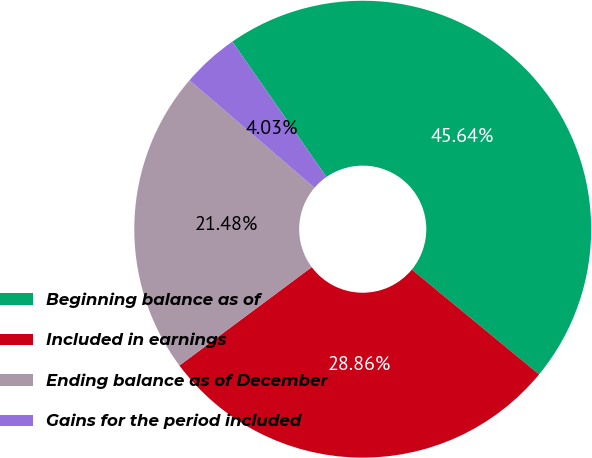<chart> <loc_0><loc_0><loc_500><loc_500><pie_chart><fcel>Beginning balance as of<fcel>Included in earnings<fcel>Ending balance as of December<fcel>Gains for the period included<nl><fcel>45.64%<fcel>28.86%<fcel>21.48%<fcel>4.03%<nl></chart> 